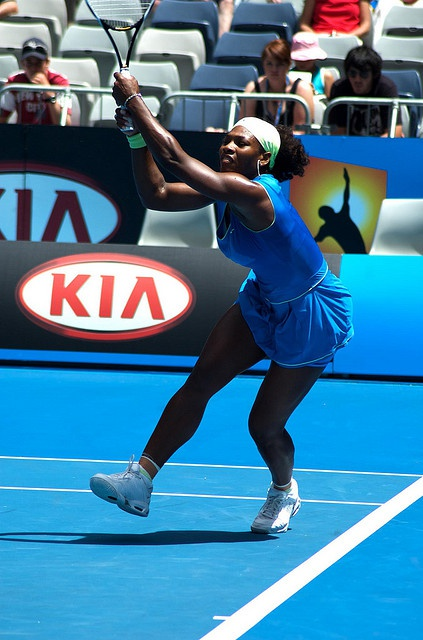Describe the objects in this image and their specific colors. I can see people in black, navy, blue, and darkblue tones, people in black, blue, and gray tones, people in black, maroon, gray, and white tones, people in black, gray, white, and maroon tones, and chair in black, lightgray, gray, and darkgray tones in this image. 